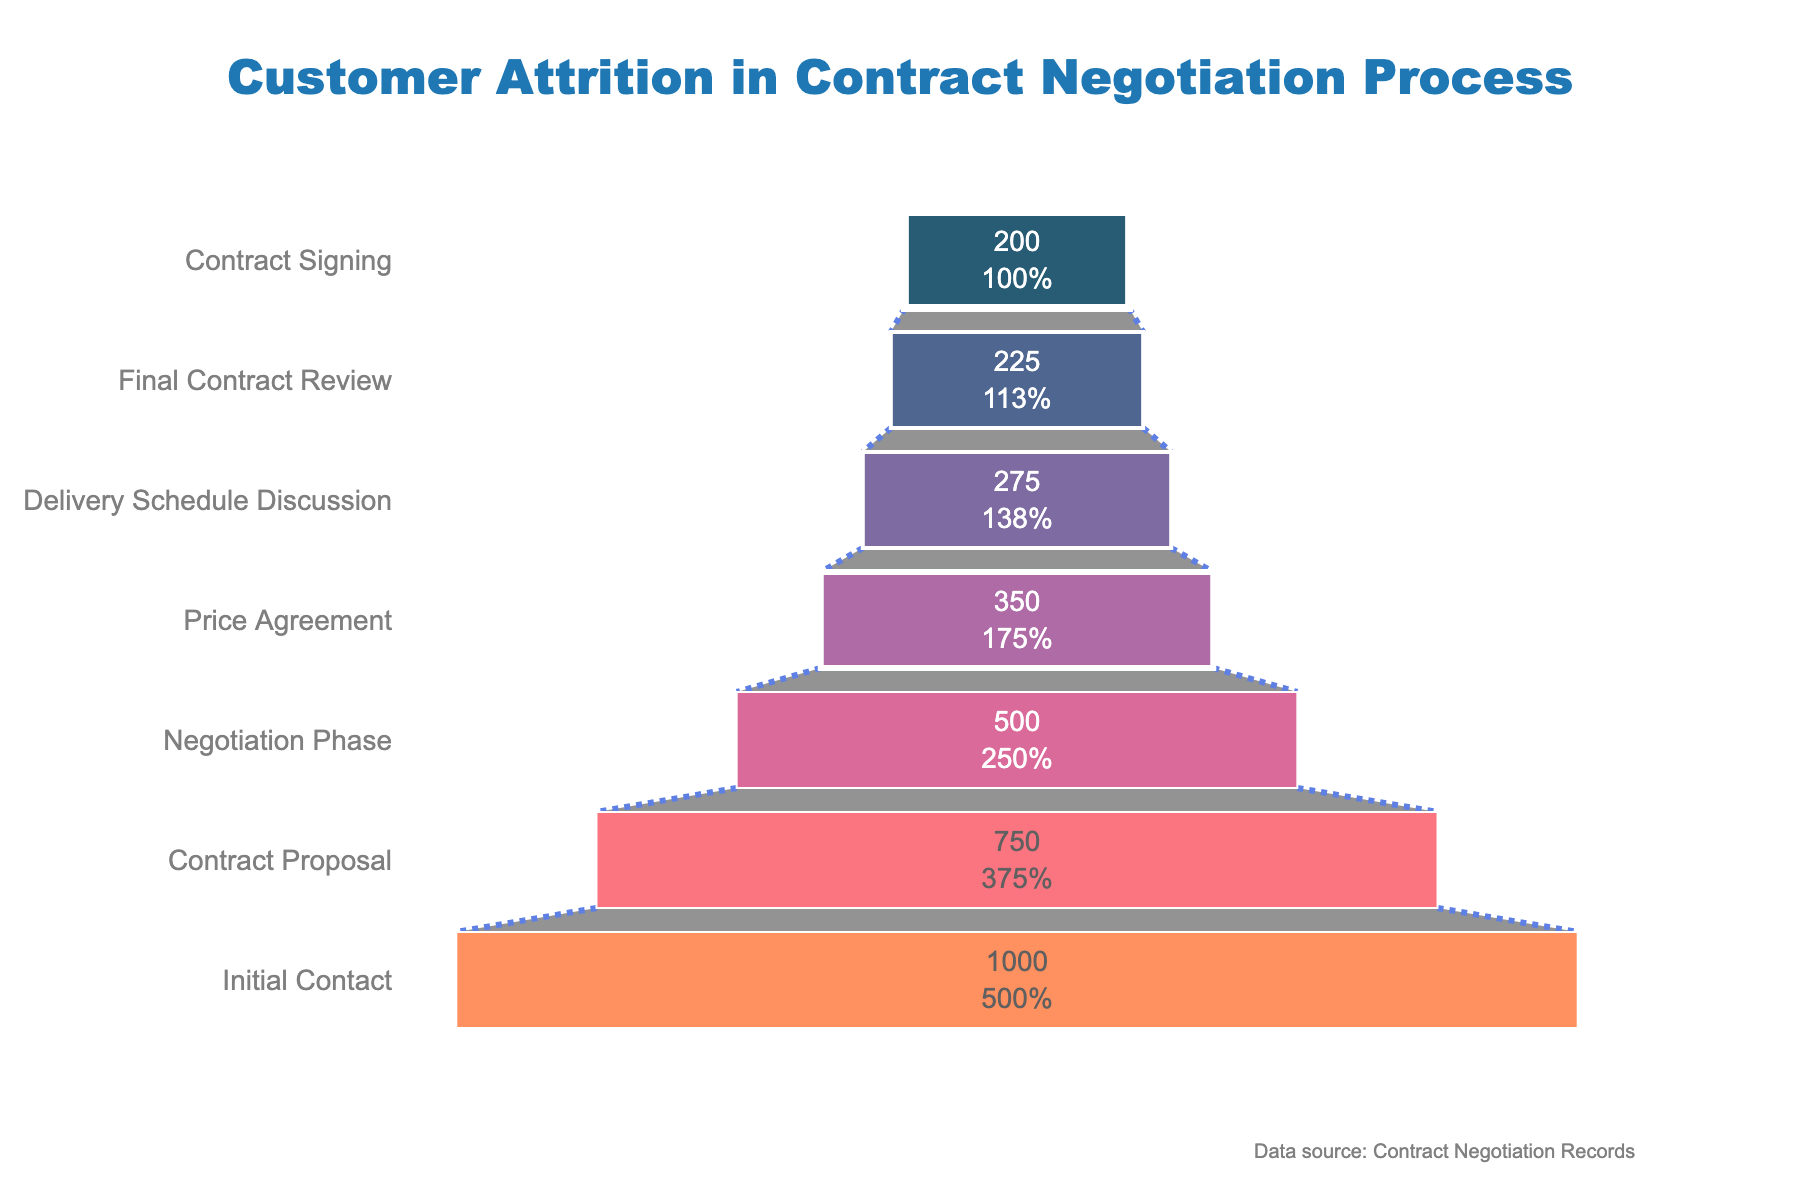What's the title of the chart? The title is positioned at the top center of the chart and reads "Customer Attrition in Contract Negotiation Process".
Answer: Customer Attrition in Contract Negotiation Process How many customers reach the Contract Signing stage? The chart shows the value of customers at each stage, and the number of customers at the Contract Signing stage is displayed as 200.
Answer: 200 What is the percentage of customers that proceed from the Contract Proposal to the Final Contract Review stage? The percentage decrease can be calculated step-by-step. Start from 750 (Contract Proposal) to 500 (Negotiation Phase), then from 500 to 350 (Price Agreement), 350 to 275 (Delivery Schedule Discussion), and finally from 275 to 225 (Final Contract Review). First, calculate the percentages for each step: 
- (500/750) *100 = 66.67%, 
- (350/500) * 100 = 70%, 
- (275/350) * 100 = 78.57%, 
- (225/275) * 100 = 81.82%. 
Now multiply these percentages for cumulative impact: 
(0.6667 * 0.70 * 0.7857 * 0.8182) = 0.3003 => 30.03%.
Answer: 30.03% Which stage shows the highest customer drop-off rate in terms of the number of customers? By examining the chart, you can see that the largest difference in customer numbers occurs between the Initial Contact stage (1000) and the Contract Proposal stage (750). The drop-off rate is 1000 - 750 = 250 customers.
Answer: Initial Contact to Contract Proposal Which stage in the funnel has the least number of customers? According to the chart, the stage with the least number of customers is the Contract Signing stage, with 200 customers.
Answer: Contract Signing What percentage of the initial 1000 customers reach the Delivery Schedule Discussion stage? The number of customers at the Delivery Schedule Discussion stage is 275. The percentage can be calculated as (275/1000) * 100.
Answer: 27.5% How many customers are lost from the Delivery Schedule Discussion stage to the Contract Signing stage? Between these stages, the number decreases from 275 to 200 customers. The difference is 275 - 200.
Answer: 75 What is the percentage decrease in customers from the Initial Contact stage to the Contract Signing stage? The decrease is from 1000 to 200 customers. Percentage decrease is calculated as ((1000 - 200) / 1000) * 100.
Answer: 80% Is the decrease in customer numbers from the Negotiation Phase to the Price Agreement stage greater than the decrease from the Price Agreement to the Delivery Schedule Discussion stage? The decrease from Negotiation Phase (500) to Price Agreement (350) is 500 - 350 = 150. The decrease from Price Agreement (350) to Delivery Schedule Discussion (275) is 350 - 275 = 75. 150 is greater than 75.
Answer: Yes If you start with 400 customers at the Final Contract Review stage, how many would you expect to sign the contract, assuming the same drop-off rate? The ratio of customers signing contract (200) from the Final Contract Review stage (225) can be applied to 400 initial customers: (200/225) * 400 = 355.56, rounded to 356 customers.
Answer: 356 